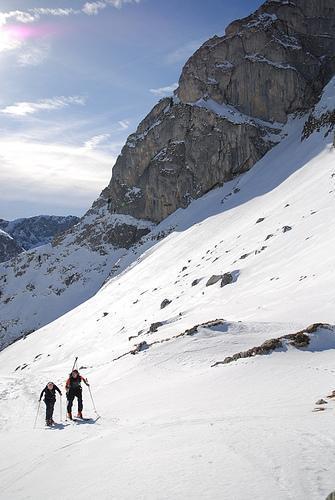How many colorful umbrellas are there?
Give a very brief answer. 0. 